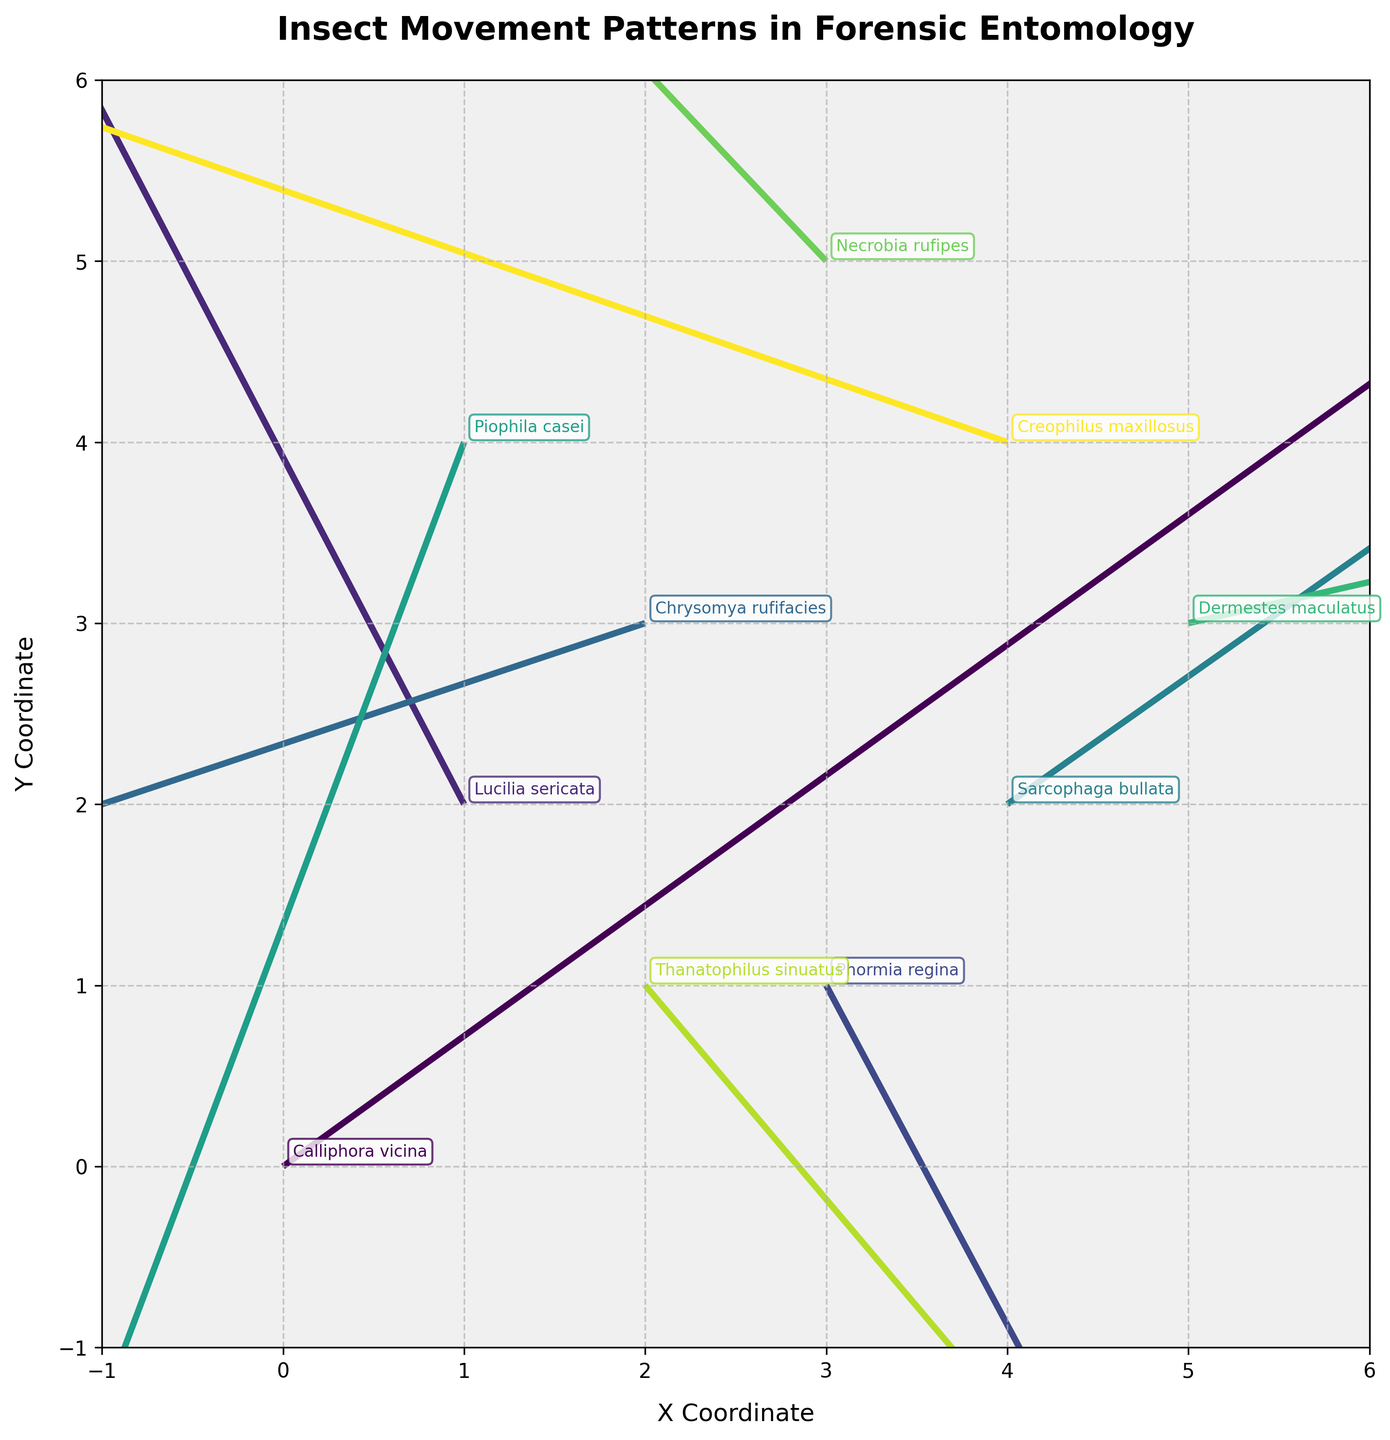What is the title of the plot? The title is clearly indicated at the top of the figure. The large, bold text reads "Insect Movement Patterns in Forensic Entomology."
Answer: Insect Movement Patterns in Forensic Entomology How many different insect species are represented in the plot? Each insect species is represented by a different color and corresponding label next to the arrows. Counting the unique labels indicates there are 10 different species.
Answer: 10 Which insect shows the longest movement vector? The vector length can be determined visually by comparing the size of the arrows. The longest vector appears to belong to "Calliphora vicina" starting at (0, 0).
Answer: Calliphora vicina What are the coordinates of the starting point of "Piophila casei"? The starting coordinates are where the arrow for "Piophila casei" begins. Visually, it starts at the point (1, 4).
Answer: (1, 4) Which insect has a movement vector directed the most towards the negative Y-axis? The direction of movement towards the negative Y-axis means that the vector points downward. "Piophila casei" has a vector most directed downward as it shows the steepest decline in the Y-coordinate (-2.4).
Answer: Piophila casei How many insects have their movement vectors starting from an X-coordinate greater than 3? Identify vectors with original X-coordinates greater than 3. The insects are "Sarcophaga bullata," "Dermestes maculatus," and "Creophilus maxillosus."
Answer: 3 Which pairs of insects have movement vectors with opposite directions in X or Y coordinates? Vectors with opposite directions will have signs reversed in either u or v components. "Sarcophaga bullata" and "Creophilus maxillosus" have opposite X-direction vectors (1.7 and -2.3), while "Calliphora vicina" and "Chrysomya rufifacies" have opposite Y-direction vectors (1.8 and -0.7).
Answer: Sarcophaga bullata & Creophilus maxillosus, Calliphora vicina & Chrysomya rufifacies What is the average Y-coordinate of the starting positions of all the insect vectors? Sum the Y-coordinates and divide by the number of points. The calculation is (0 + 2 + 1 + 3 + 2 + 4 + 3 + 5 + 1 + 4)/10 = 2.5.
Answer: 2.5 Which insect's movement pattern has the smallest magnitude? Magnitude of the vector is calculated using the formula √(u² + v²). "Thanatophilus sinuatus" has the smallest magnitude with √(1.1² + (-1.3)²) ≈ 1.70.
Answer: Thanatophilus sinuatus 